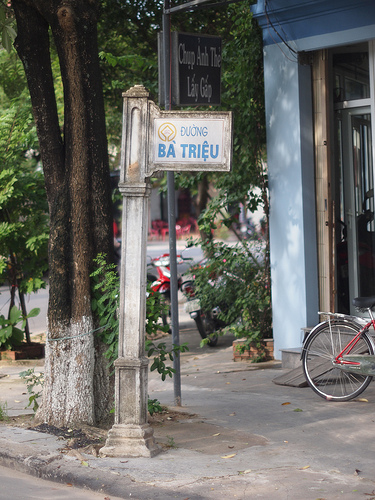What can you imagine happens in this place early in the morning? In the early morning, this street might be filled with the quiet hustle of people starting their day. A newspaper vendor might set up shop, small food stalls may begin to open, and passersby could be seen engaging in morning rituals like jogging or walking their dogs. The cool, calm morning air adds a serene ambiance as the area starts to come alive. Can you create a story about someone who regularly visits this place? Every morning, Mr. Nguyen, a retired local, visits this street. With a warm smile, he greets familiar vendors and shops at the market for fresh produce. His mornings are filled with small conversations and the joy of community. With his bicycle, he travels to this spot not just for groceries but for the sense of belonging it brings him, finding comfort in the predictable rhythm of life here. He often sits on a bench, reminiscing about the stories and experiences he's gathered over the years, watching the place transform as the day progresses. 